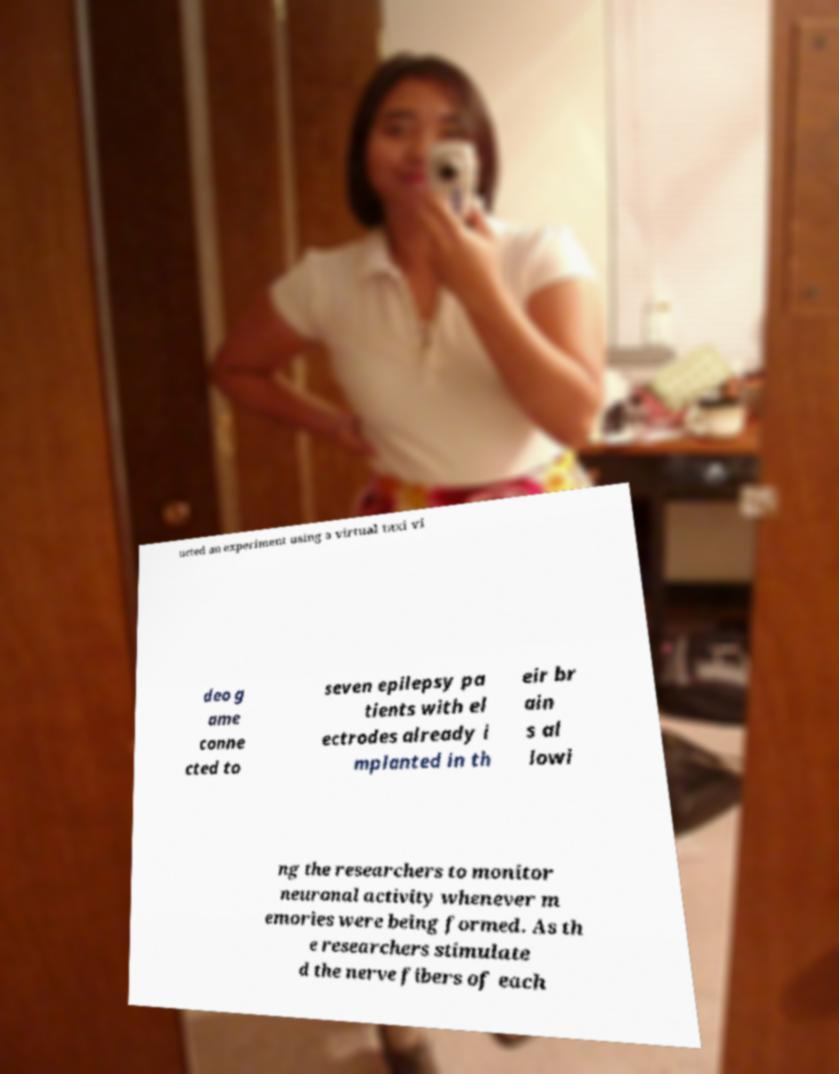Please identify and transcribe the text found in this image. ucted an experiment using a virtual taxi vi deo g ame conne cted to seven epilepsy pa tients with el ectrodes already i mplanted in th eir br ain s al lowi ng the researchers to monitor neuronal activity whenever m emories were being formed. As th e researchers stimulate d the nerve fibers of each 